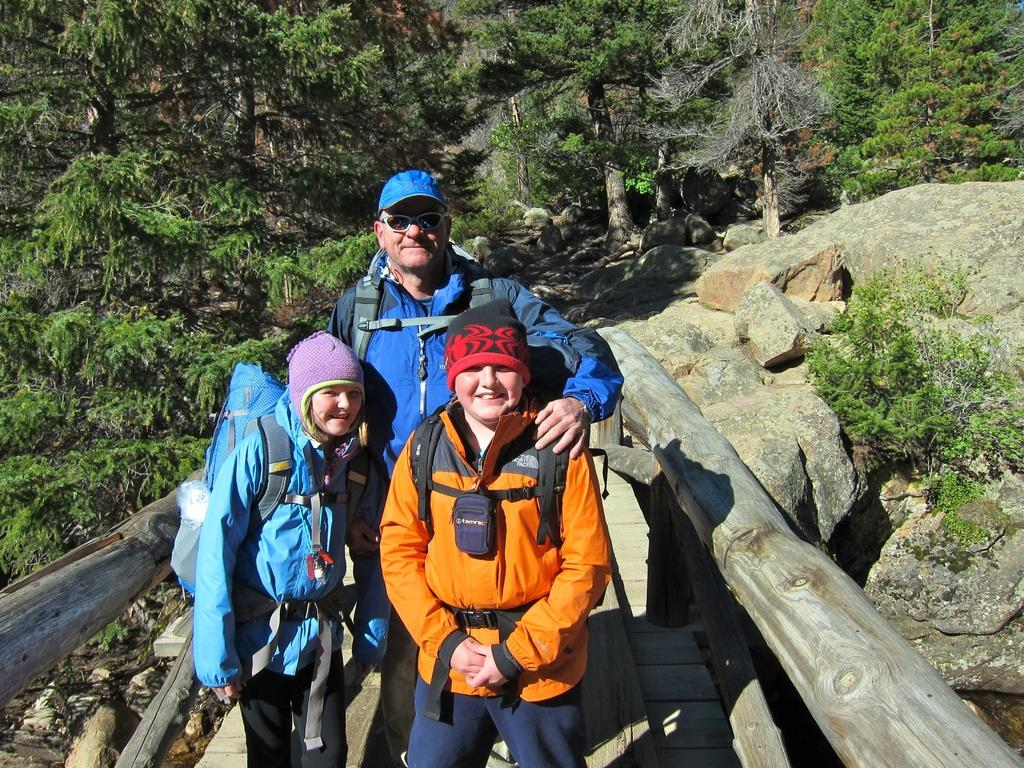What are the people in the image standing on? The people are standing on a wooden bridge. What are the people wearing on their heads? The people are wearing caps. What can be seen in the background of the image? There are trees and stones in the background of the image. What type of dust can be seen on the bridge in the image? There is no dust visible on the bridge in the image. 